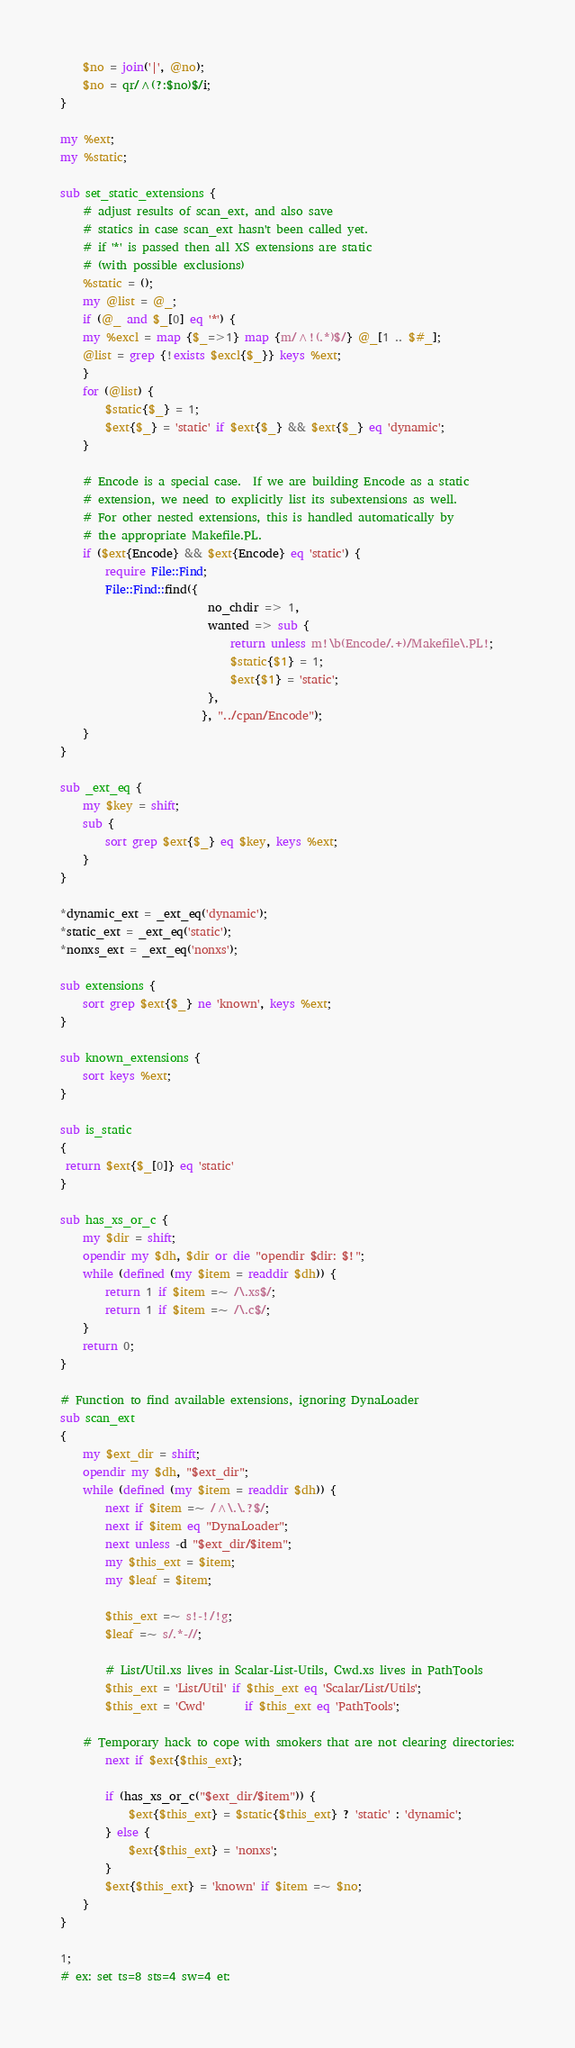Convert code to text. <code><loc_0><loc_0><loc_500><loc_500><_Perl_>
    $no = join('|', @no);
    $no = qr/^(?:$no)$/i;
}

my %ext;
my %static;

sub set_static_extensions {
    # adjust results of scan_ext, and also save
    # statics in case scan_ext hasn't been called yet.
    # if '*' is passed then all XS extensions are static
    # (with possible exclusions)
    %static = ();
    my @list = @_;
    if (@_ and $_[0] eq '*') {
	my %excl = map {$_=>1} map {m/^!(.*)$/} @_[1 .. $#_];
	@list = grep {!exists $excl{$_}} keys %ext;
    }
    for (@list) {
        $static{$_} = 1;
        $ext{$_} = 'static' if $ext{$_} && $ext{$_} eq 'dynamic';
    }

    # Encode is a special case.  If we are building Encode as a static
    # extension, we need to explicitly list its subextensions as well.
    # For other nested extensions, this is handled automatically by
    # the appropriate Makefile.PL.
    if ($ext{Encode} && $ext{Encode} eq 'static') {
        require File::Find;
        File::Find::find({
                          no_chdir => 1,
                          wanted => sub {
                              return unless m!\b(Encode/.+)/Makefile\.PL!;
                              $static{$1} = 1;
                              $ext{$1} = 'static';
                          },
                         }, "../cpan/Encode");
    }
}

sub _ext_eq {
    my $key = shift;
    sub {
        sort grep $ext{$_} eq $key, keys %ext;
    }
}

*dynamic_ext = _ext_eq('dynamic');
*static_ext = _ext_eq('static');
*nonxs_ext = _ext_eq('nonxs');

sub extensions {
    sort grep $ext{$_} ne 'known', keys %ext;
}

sub known_extensions {
    sort keys %ext;
}

sub is_static
{
 return $ext{$_[0]} eq 'static'
}

sub has_xs_or_c {
    my $dir = shift;
    opendir my $dh, $dir or die "opendir $dir: $!";
    while (defined (my $item = readdir $dh)) {
        return 1 if $item =~ /\.xs$/;
        return 1 if $item =~ /\.c$/;
    }
    return 0;
}

# Function to find available extensions, ignoring DynaLoader
sub scan_ext
{
    my $ext_dir = shift;
    opendir my $dh, "$ext_dir";
    while (defined (my $item = readdir $dh)) {
        next if $item =~ /^\.\.?$/;
        next if $item eq "DynaLoader";
        next unless -d "$ext_dir/$item";
        my $this_ext = $item;
        my $leaf = $item;

        $this_ext =~ s!-!/!g;
        $leaf =~ s/.*-//;

        # List/Util.xs lives in Scalar-List-Utils, Cwd.xs lives in PathTools
        $this_ext = 'List/Util' if $this_ext eq 'Scalar/List/Utils';
        $this_ext = 'Cwd'       if $this_ext eq 'PathTools';

	# Temporary hack to cope with smokers that are not clearing directories:
        next if $ext{$this_ext};

        if (has_xs_or_c("$ext_dir/$item")) {
            $ext{$this_ext} = $static{$this_ext} ? 'static' : 'dynamic';
        } else {
            $ext{$this_ext} = 'nonxs';
        }
        $ext{$this_ext} = 'known' if $item =~ $no;
    }
}

1;
# ex: set ts=8 sts=4 sw=4 et:
</code> 